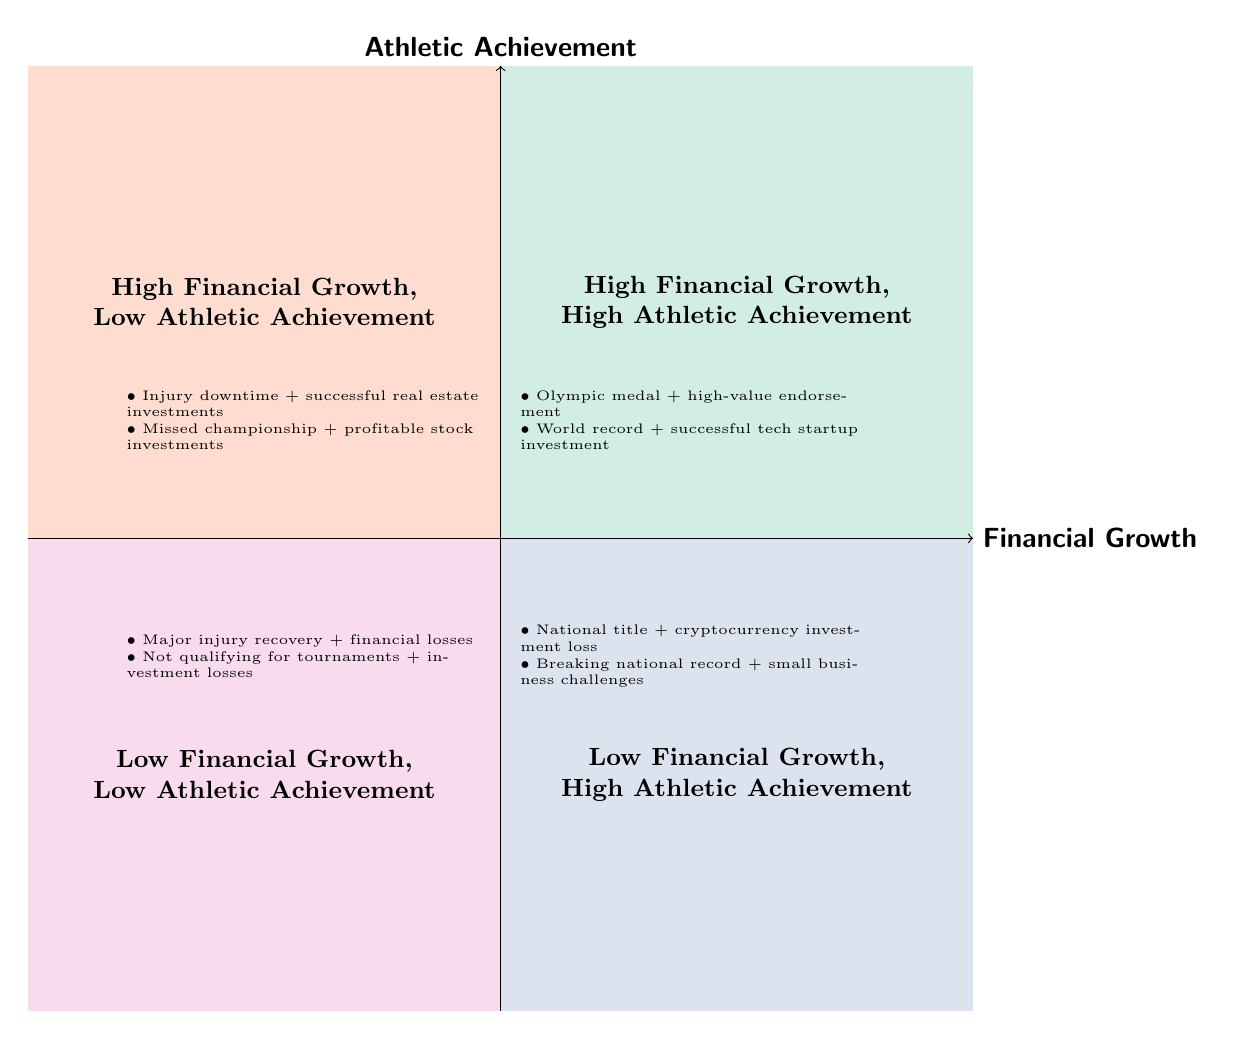What do the titles of the quadrants indicate? The titles of the quadrants represent different combinations of personal financial growth and athletic achievements. These titles help categorize the overall success or challenges faced by the athlete, depending on whether both aspects are high, low, or a mix of both.
Answer: Different combinations of financial growth and athletic achievements How many quadrants are present in the diagram? The diagram consists of four distinct quadrants, each representing a different relationship between financial growth and athletic achievement.
Answer: Four What examples are provided in the High Financial Growth, Low Athletic Achievement quadrant? The examples for this quadrant include "Injury downtime but successful real estate investments" and "Missed championship season but profitable stock investments," showing cases where financial success occurred despite athletic struggles.
Answer: Injury downtime successful real estate investments; Missed championship profitable stock investments Which quadrant depicts both low financial growth and high athletic achievement? The quadrant labeled "Low Financial Growth, High Athletic Achievement" represents periods of significant athletic success where investments did not perform well.
Answer: Low Financial Growth, High Athletic Achievement What signifies the High Financial Growth, High Athletic Achievement quadrant? This quadrant signifies periods where an athlete simultaneously enjoys notable athletic accomplishments and substantial financial success from investments, creating a scenario of overall success.
Answer: Significant overall success What is the relationship between the second and fourth quadrants? The second quadrant ("High Financial Growth, Low Athletic Achievement") represents times of financial success during athletic struggles, whereas the fourth quadrant ("Low Financial Growth, Low Athletic Achievement") shows periods of failure in both areas. This implies that the athlete experiences financial growth independently from athletic success in the second quadrant but struggles in both conditions in the fourth.
Answer: Financial success vs. struggles in both areas Which quadrant illustrates recovery from injury and financial losses? The "Low Financial Growth, Low Athletic Achievement" quadrant illustrates periods of recovering from injuries while also facing financial losses due to market conditions.
Answer: Low Financial Growth, Low Athletic Achievement What is the significance of winning an Olympic medal in relation to financial growth? Winning an Olympic medal is located in the "High Financial Growth, High Athletic Achievement" quadrant, indicating that this achievement can align with lucrative financial opportunities, such as endorsement deals, highlighting a moment of dual success.
Answer: Significant opportunity for lucrative financial growth 